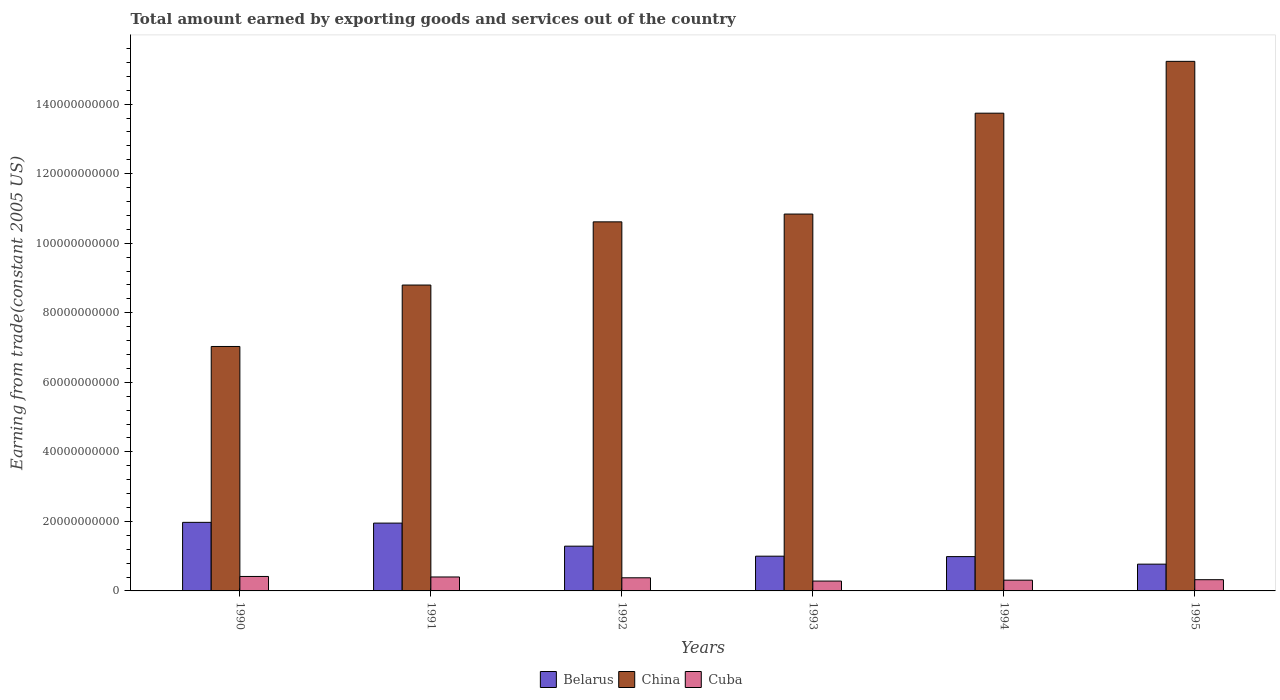How many groups of bars are there?
Offer a terse response. 6. Are the number of bars per tick equal to the number of legend labels?
Your answer should be very brief. Yes. Are the number of bars on each tick of the X-axis equal?
Your response must be concise. Yes. How many bars are there on the 1st tick from the left?
Offer a terse response. 3. How many bars are there on the 2nd tick from the right?
Provide a succinct answer. 3. In how many cases, is the number of bars for a given year not equal to the number of legend labels?
Your response must be concise. 0. What is the total amount earned by exporting goods and services in Belarus in 1993?
Ensure brevity in your answer.  9.99e+09. Across all years, what is the maximum total amount earned by exporting goods and services in Cuba?
Keep it short and to the point. 4.16e+09. Across all years, what is the minimum total amount earned by exporting goods and services in Cuba?
Your answer should be compact. 2.83e+09. In which year was the total amount earned by exporting goods and services in Belarus maximum?
Your answer should be compact. 1990. What is the total total amount earned by exporting goods and services in Cuba in the graph?
Keep it short and to the point. 2.11e+1. What is the difference between the total amount earned by exporting goods and services in China in 1991 and that in 1993?
Your response must be concise. -2.04e+1. What is the difference between the total amount earned by exporting goods and services in Cuba in 1993 and the total amount earned by exporting goods and services in Belarus in 1991?
Ensure brevity in your answer.  -1.67e+1. What is the average total amount earned by exporting goods and services in Cuba per year?
Provide a short and direct response. 3.52e+09. In the year 1994, what is the difference between the total amount earned by exporting goods and services in China and total amount earned by exporting goods and services in Belarus?
Provide a succinct answer. 1.28e+11. What is the ratio of the total amount earned by exporting goods and services in China in 1993 to that in 1994?
Your answer should be compact. 0.79. What is the difference between the highest and the second highest total amount earned by exporting goods and services in China?
Give a very brief answer. 1.49e+1. What is the difference between the highest and the lowest total amount earned by exporting goods and services in Belarus?
Ensure brevity in your answer.  1.20e+1. What does the 3rd bar from the left in 1992 represents?
Make the answer very short. Cuba. What does the 3rd bar from the right in 1993 represents?
Your answer should be compact. Belarus. How many bars are there?
Your answer should be very brief. 18. Are all the bars in the graph horizontal?
Keep it short and to the point. No. What is the difference between two consecutive major ticks on the Y-axis?
Ensure brevity in your answer.  2.00e+1. Where does the legend appear in the graph?
Give a very brief answer. Bottom center. How are the legend labels stacked?
Keep it short and to the point. Horizontal. What is the title of the graph?
Provide a succinct answer. Total amount earned by exporting goods and services out of the country. What is the label or title of the X-axis?
Make the answer very short. Years. What is the label or title of the Y-axis?
Your answer should be very brief. Earning from trade(constant 2005 US). What is the Earning from trade(constant 2005 US) of Belarus in 1990?
Your answer should be very brief. 1.97e+1. What is the Earning from trade(constant 2005 US) in China in 1990?
Your answer should be very brief. 7.03e+1. What is the Earning from trade(constant 2005 US) of Cuba in 1990?
Offer a very short reply. 4.16e+09. What is the Earning from trade(constant 2005 US) in Belarus in 1991?
Provide a short and direct response. 1.95e+1. What is the Earning from trade(constant 2005 US) of China in 1991?
Offer a terse response. 8.80e+1. What is the Earning from trade(constant 2005 US) of Cuba in 1991?
Give a very brief answer. 4.01e+09. What is the Earning from trade(constant 2005 US) in Belarus in 1992?
Give a very brief answer. 1.29e+1. What is the Earning from trade(constant 2005 US) of China in 1992?
Your answer should be very brief. 1.06e+11. What is the Earning from trade(constant 2005 US) of Cuba in 1992?
Make the answer very short. 3.77e+09. What is the Earning from trade(constant 2005 US) in Belarus in 1993?
Ensure brevity in your answer.  9.99e+09. What is the Earning from trade(constant 2005 US) in China in 1993?
Offer a very short reply. 1.08e+11. What is the Earning from trade(constant 2005 US) in Cuba in 1993?
Offer a terse response. 2.83e+09. What is the Earning from trade(constant 2005 US) of Belarus in 1994?
Keep it short and to the point. 9.87e+09. What is the Earning from trade(constant 2005 US) in China in 1994?
Make the answer very short. 1.37e+11. What is the Earning from trade(constant 2005 US) of Cuba in 1994?
Make the answer very short. 3.09e+09. What is the Earning from trade(constant 2005 US) in Belarus in 1995?
Give a very brief answer. 7.70e+09. What is the Earning from trade(constant 2005 US) of China in 1995?
Ensure brevity in your answer.  1.52e+11. What is the Earning from trade(constant 2005 US) of Cuba in 1995?
Ensure brevity in your answer.  3.23e+09. Across all years, what is the maximum Earning from trade(constant 2005 US) in Belarus?
Make the answer very short. 1.97e+1. Across all years, what is the maximum Earning from trade(constant 2005 US) of China?
Provide a succinct answer. 1.52e+11. Across all years, what is the maximum Earning from trade(constant 2005 US) of Cuba?
Your answer should be very brief. 4.16e+09. Across all years, what is the minimum Earning from trade(constant 2005 US) in Belarus?
Make the answer very short. 7.70e+09. Across all years, what is the minimum Earning from trade(constant 2005 US) of China?
Your answer should be very brief. 7.03e+1. Across all years, what is the minimum Earning from trade(constant 2005 US) of Cuba?
Make the answer very short. 2.83e+09. What is the total Earning from trade(constant 2005 US) of Belarus in the graph?
Your response must be concise. 7.97e+1. What is the total Earning from trade(constant 2005 US) in China in the graph?
Your response must be concise. 6.62e+11. What is the total Earning from trade(constant 2005 US) in Cuba in the graph?
Your response must be concise. 2.11e+1. What is the difference between the Earning from trade(constant 2005 US) of Belarus in 1990 and that in 1991?
Your response must be concise. 2.17e+08. What is the difference between the Earning from trade(constant 2005 US) of China in 1990 and that in 1991?
Your response must be concise. -1.77e+1. What is the difference between the Earning from trade(constant 2005 US) in Cuba in 1990 and that in 1991?
Keep it short and to the point. 1.47e+08. What is the difference between the Earning from trade(constant 2005 US) of Belarus in 1990 and that in 1992?
Provide a succinct answer. 6.85e+09. What is the difference between the Earning from trade(constant 2005 US) of China in 1990 and that in 1992?
Keep it short and to the point. -3.58e+1. What is the difference between the Earning from trade(constant 2005 US) in Cuba in 1990 and that in 1992?
Your answer should be very brief. 3.84e+08. What is the difference between the Earning from trade(constant 2005 US) of Belarus in 1990 and that in 1993?
Your answer should be very brief. 9.73e+09. What is the difference between the Earning from trade(constant 2005 US) in China in 1990 and that in 1993?
Make the answer very short. -3.81e+1. What is the difference between the Earning from trade(constant 2005 US) in Cuba in 1990 and that in 1993?
Make the answer very short. 1.32e+09. What is the difference between the Earning from trade(constant 2005 US) of Belarus in 1990 and that in 1994?
Provide a succinct answer. 9.85e+09. What is the difference between the Earning from trade(constant 2005 US) in China in 1990 and that in 1994?
Offer a terse response. -6.71e+1. What is the difference between the Earning from trade(constant 2005 US) of Cuba in 1990 and that in 1994?
Offer a very short reply. 1.07e+09. What is the difference between the Earning from trade(constant 2005 US) of Belarus in 1990 and that in 1995?
Your answer should be very brief. 1.20e+1. What is the difference between the Earning from trade(constant 2005 US) of China in 1990 and that in 1995?
Your answer should be very brief. -8.20e+1. What is the difference between the Earning from trade(constant 2005 US) in Cuba in 1990 and that in 1995?
Your answer should be compact. 9.32e+08. What is the difference between the Earning from trade(constant 2005 US) of Belarus in 1991 and that in 1992?
Keep it short and to the point. 6.63e+09. What is the difference between the Earning from trade(constant 2005 US) of China in 1991 and that in 1992?
Your answer should be very brief. -1.82e+1. What is the difference between the Earning from trade(constant 2005 US) of Cuba in 1991 and that in 1992?
Your response must be concise. 2.37e+08. What is the difference between the Earning from trade(constant 2005 US) in Belarus in 1991 and that in 1993?
Offer a very short reply. 9.51e+09. What is the difference between the Earning from trade(constant 2005 US) in China in 1991 and that in 1993?
Provide a succinct answer. -2.04e+1. What is the difference between the Earning from trade(constant 2005 US) in Cuba in 1991 and that in 1993?
Offer a very short reply. 1.18e+09. What is the difference between the Earning from trade(constant 2005 US) in Belarus in 1991 and that in 1994?
Keep it short and to the point. 9.63e+09. What is the difference between the Earning from trade(constant 2005 US) of China in 1991 and that in 1994?
Provide a succinct answer. -4.94e+1. What is the difference between the Earning from trade(constant 2005 US) of Cuba in 1991 and that in 1994?
Offer a terse response. 9.20e+08. What is the difference between the Earning from trade(constant 2005 US) in Belarus in 1991 and that in 1995?
Your answer should be compact. 1.18e+1. What is the difference between the Earning from trade(constant 2005 US) of China in 1991 and that in 1995?
Offer a terse response. -6.43e+1. What is the difference between the Earning from trade(constant 2005 US) in Cuba in 1991 and that in 1995?
Make the answer very short. 7.86e+08. What is the difference between the Earning from trade(constant 2005 US) in Belarus in 1992 and that in 1993?
Keep it short and to the point. 2.88e+09. What is the difference between the Earning from trade(constant 2005 US) in China in 1992 and that in 1993?
Your answer should be very brief. -2.24e+09. What is the difference between the Earning from trade(constant 2005 US) in Cuba in 1992 and that in 1993?
Keep it short and to the point. 9.41e+08. What is the difference between the Earning from trade(constant 2005 US) of Belarus in 1992 and that in 1994?
Keep it short and to the point. 3.00e+09. What is the difference between the Earning from trade(constant 2005 US) in China in 1992 and that in 1994?
Make the answer very short. -3.13e+1. What is the difference between the Earning from trade(constant 2005 US) in Cuba in 1992 and that in 1994?
Offer a terse response. 6.82e+08. What is the difference between the Earning from trade(constant 2005 US) of Belarus in 1992 and that in 1995?
Provide a succinct answer. 5.17e+09. What is the difference between the Earning from trade(constant 2005 US) in China in 1992 and that in 1995?
Your answer should be very brief. -4.62e+1. What is the difference between the Earning from trade(constant 2005 US) in Cuba in 1992 and that in 1995?
Your answer should be compact. 5.48e+08. What is the difference between the Earning from trade(constant 2005 US) in Belarus in 1993 and that in 1994?
Provide a succinct answer. 1.20e+08. What is the difference between the Earning from trade(constant 2005 US) of China in 1993 and that in 1994?
Keep it short and to the point. -2.90e+1. What is the difference between the Earning from trade(constant 2005 US) in Cuba in 1993 and that in 1994?
Make the answer very short. -2.58e+08. What is the difference between the Earning from trade(constant 2005 US) of Belarus in 1993 and that in 1995?
Your response must be concise. 2.29e+09. What is the difference between the Earning from trade(constant 2005 US) in China in 1993 and that in 1995?
Give a very brief answer. -4.39e+1. What is the difference between the Earning from trade(constant 2005 US) in Cuba in 1993 and that in 1995?
Offer a terse response. -3.92e+08. What is the difference between the Earning from trade(constant 2005 US) of Belarus in 1994 and that in 1995?
Your response must be concise. 2.17e+09. What is the difference between the Earning from trade(constant 2005 US) in China in 1994 and that in 1995?
Provide a succinct answer. -1.49e+1. What is the difference between the Earning from trade(constant 2005 US) of Cuba in 1994 and that in 1995?
Offer a very short reply. -1.34e+08. What is the difference between the Earning from trade(constant 2005 US) in Belarus in 1990 and the Earning from trade(constant 2005 US) in China in 1991?
Provide a short and direct response. -6.82e+1. What is the difference between the Earning from trade(constant 2005 US) of Belarus in 1990 and the Earning from trade(constant 2005 US) of Cuba in 1991?
Your response must be concise. 1.57e+1. What is the difference between the Earning from trade(constant 2005 US) in China in 1990 and the Earning from trade(constant 2005 US) in Cuba in 1991?
Offer a very short reply. 6.63e+1. What is the difference between the Earning from trade(constant 2005 US) in Belarus in 1990 and the Earning from trade(constant 2005 US) in China in 1992?
Ensure brevity in your answer.  -8.64e+1. What is the difference between the Earning from trade(constant 2005 US) of Belarus in 1990 and the Earning from trade(constant 2005 US) of Cuba in 1992?
Your answer should be compact. 1.59e+1. What is the difference between the Earning from trade(constant 2005 US) in China in 1990 and the Earning from trade(constant 2005 US) in Cuba in 1992?
Provide a short and direct response. 6.65e+1. What is the difference between the Earning from trade(constant 2005 US) in Belarus in 1990 and the Earning from trade(constant 2005 US) in China in 1993?
Give a very brief answer. -8.87e+1. What is the difference between the Earning from trade(constant 2005 US) of Belarus in 1990 and the Earning from trade(constant 2005 US) of Cuba in 1993?
Provide a succinct answer. 1.69e+1. What is the difference between the Earning from trade(constant 2005 US) in China in 1990 and the Earning from trade(constant 2005 US) in Cuba in 1993?
Make the answer very short. 6.75e+1. What is the difference between the Earning from trade(constant 2005 US) in Belarus in 1990 and the Earning from trade(constant 2005 US) in China in 1994?
Provide a succinct answer. -1.18e+11. What is the difference between the Earning from trade(constant 2005 US) of Belarus in 1990 and the Earning from trade(constant 2005 US) of Cuba in 1994?
Your response must be concise. 1.66e+1. What is the difference between the Earning from trade(constant 2005 US) in China in 1990 and the Earning from trade(constant 2005 US) in Cuba in 1994?
Provide a succinct answer. 6.72e+1. What is the difference between the Earning from trade(constant 2005 US) of Belarus in 1990 and the Earning from trade(constant 2005 US) of China in 1995?
Make the answer very short. -1.33e+11. What is the difference between the Earning from trade(constant 2005 US) of Belarus in 1990 and the Earning from trade(constant 2005 US) of Cuba in 1995?
Make the answer very short. 1.65e+1. What is the difference between the Earning from trade(constant 2005 US) of China in 1990 and the Earning from trade(constant 2005 US) of Cuba in 1995?
Ensure brevity in your answer.  6.71e+1. What is the difference between the Earning from trade(constant 2005 US) of Belarus in 1991 and the Earning from trade(constant 2005 US) of China in 1992?
Your answer should be compact. -8.66e+1. What is the difference between the Earning from trade(constant 2005 US) in Belarus in 1991 and the Earning from trade(constant 2005 US) in Cuba in 1992?
Ensure brevity in your answer.  1.57e+1. What is the difference between the Earning from trade(constant 2005 US) of China in 1991 and the Earning from trade(constant 2005 US) of Cuba in 1992?
Provide a succinct answer. 8.42e+1. What is the difference between the Earning from trade(constant 2005 US) in Belarus in 1991 and the Earning from trade(constant 2005 US) in China in 1993?
Your response must be concise. -8.89e+1. What is the difference between the Earning from trade(constant 2005 US) in Belarus in 1991 and the Earning from trade(constant 2005 US) in Cuba in 1993?
Ensure brevity in your answer.  1.67e+1. What is the difference between the Earning from trade(constant 2005 US) in China in 1991 and the Earning from trade(constant 2005 US) in Cuba in 1993?
Offer a terse response. 8.51e+1. What is the difference between the Earning from trade(constant 2005 US) in Belarus in 1991 and the Earning from trade(constant 2005 US) in China in 1994?
Provide a succinct answer. -1.18e+11. What is the difference between the Earning from trade(constant 2005 US) of Belarus in 1991 and the Earning from trade(constant 2005 US) of Cuba in 1994?
Your answer should be compact. 1.64e+1. What is the difference between the Earning from trade(constant 2005 US) of China in 1991 and the Earning from trade(constant 2005 US) of Cuba in 1994?
Provide a succinct answer. 8.49e+1. What is the difference between the Earning from trade(constant 2005 US) in Belarus in 1991 and the Earning from trade(constant 2005 US) in China in 1995?
Offer a terse response. -1.33e+11. What is the difference between the Earning from trade(constant 2005 US) in Belarus in 1991 and the Earning from trade(constant 2005 US) in Cuba in 1995?
Your answer should be compact. 1.63e+1. What is the difference between the Earning from trade(constant 2005 US) in China in 1991 and the Earning from trade(constant 2005 US) in Cuba in 1995?
Provide a short and direct response. 8.47e+1. What is the difference between the Earning from trade(constant 2005 US) in Belarus in 1992 and the Earning from trade(constant 2005 US) in China in 1993?
Give a very brief answer. -9.55e+1. What is the difference between the Earning from trade(constant 2005 US) in Belarus in 1992 and the Earning from trade(constant 2005 US) in Cuba in 1993?
Provide a succinct answer. 1.00e+1. What is the difference between the Earning from trade(constant 2005 US) in China in 1992 and the Earning from trade(constant 2005 US) in Cuba in 1993?
Keep it short and to the point. 1.03e+11. What is the difference between the Earning from trade(constant 2005 US) in Belarus in 1992 and the Earning from trade(constant 2005 US) in China in 1994?
Provide a short and direct response. -1.25e+11. What is the difference between the Earning from trade(constant 2005 US) of Belarus in 1992 and the Earning from trade(constant 2005 US) of Cuba in 1994?
Your answer should be compact. 9.78e+09. What is the difference between the Earning from trade(constant 2005 US) of China in 1992 and the Earning from trade(constant 2005 US) of Cuba in 1994?
Offer a very short reply. 1.03e+11. What is the difference between the Earning from trade(constant 2005 US) of Belarus in 1992 and the Earning from trade(constant 2005 US) of China in 1995?
Make the answer very short. -1.39e+11. What is the difference between the Earning from trade(constant 2005 US) of Belarus in 1992 and the Earning from trade(constant 2005 US) of Cuba in 1995?
Your answer should be compact. 9.65e+09. What is the difference between the Earning from trade(constant 2005 US) in China in 1992 and the Earning from trade(constant 2005 US) in Cuba in 1995?
Provide a succinct answer. 1.03e+11. What is the difference between the Earning from trade(constant 2005 US) of Belarus in 1993 and the Earning from trade(constant 2005 US) of China in 1994?
Offer a terse response. -1.27e+11. What is the difference between the Earning from trade(constant 2005 US) in Belarus in 1993 and the Earning from trade(constant 2005 US) in Cuba in 1994?
Ensure brevity in your answer.  6.90e+09. What is the difference between the Earning from trade(constant 2005 US) in China in 1993 and the Earning from trade(constant 2005 US) in Cuba in 1994?
Give a very brief answer. 1.05e+11. What is the difference between the Earning from trade(constant 2005 US) in Belarus in 1993 and the Earning from trade(constant 2005 US) in China in 1995?
Give a very brief answer. -1.42e+11. What is the difference between the Earning from trade(constant 2005 US) in Belarus in 1993 and the Earning from trade(constant 2005 US) in Cuba in 1995?
Your answer should be compact. 6.76e+09. What is the difference between the Earning from trade(constant 2005 US) of China in 1993 and the Earning from trade(constant 2005 US) of Cuba in 1995?
Your response must be concise. 1.05e+11. What is the difference between the Earning from trade(constant 2005 US) in Belarus in 1994 and the Earning from trade(constant 2005 US) in China in 1995?
Your answer should be very brief. -1.42e+11. What is the difference between the Earning from trade(constant 2005 US) of Belarus in 1994 and the Earning from trade(constant 2005 US) of Cuba in 1995?
Your answer should be compact. 6.64e+09. What is the difference between the Earning from trade(constant 2005 US) in China in 1994 and the Earning from trade(constant 2005 US) in Cuba in 1995?
Offer a very short reply. 1.34e+11. What is the average Earning from trade(constant 2005 US) of Belarus per year?
Keep it short and to the point. 1.33e+1. What is the average Earning from trade(constant 2005 US) of China per year?
Provide a succinct answer. 1.10e+11. What is the average Earning from trade(constant 2005 US) in Cuba per year?
Ensure brevity in your answer.  3.52e+09. In the year 1990, what is the difference between the Earning from trade(constant 2005 US) in Belarus and Earning from trade(constant 2005 US) in China?
Offer a very short reply. -5.06e+1. In the year 1990, what is the difference between the Earning from trade(constant 2005 US) of Belarus and Earning from trade(constant 2005 US) of Cuba?
Keep it short and to the point. 1.56e+1. In the year 1990, what is the difference between the Earning from trade(constant 2005 US) of China and Earning from trade(constant 2005 US) of Cuba?
Provide a short and direct response. 6.61e+1. In the year 1991, what is the difference between the Earning from trade(constant 2005 US) in Belarus and Earning from trade(constant 2005 US) in China?
Your response must be concise. -6.85e+1. In the year 1991, what is the difference between the Earning from trade(constant 2005 US) in Belarus and Earning from trade(constant 2005 US) in Cuba?
Offer a very short reply. 1.55e+1. In the year 1991, what is the difference between the Earning from trade(constant 2005 US) of China and Earning from trade(constant 2005 US) of Cuba?
Ensure brevity in your answer.  8.40e+1. In the year 1992, what is the difference between the Earning from trade(constant 2005 US) in Belarus and Earning from trade(constant 2005 US) in China?
Your answer should be very brief. -9.33e+1. In the year 1992, what is the difference between the Earning from trade(constant 2005 US) of Belarus and Earning from trade(constant 2005 US) of Cuba?
Ensure brevity in your answer.  9.10e+09. In the year 1992, what is the difference between the Earning from trade(constant 2005 US) of China and Earning from trade(constant 2005 US) of Cuba?
Provide a short and direct response. 1.02e+11. In the year 1993, what is the difference between the Earning from trade(constant 2005 US) of Belarus and Earning from trade(constant 2005 US) of China?
Your answer should be compact. -9.84e+1. In the year 1993, what is the difference between the Earning from trade(constant 2005 US) in Belarus and Earning from trade(constant 2005 US) in Cuba?
Provide a succinct answer. 7.16e+09. In the year 1993, what is the difference between the Earning from trade(constant 2005 US) of China and Earning from trade(constant 2005 US) of Cuba?
Your answer should be compact. 1.06e+11. In the year 1994, what is the difference between the Earning from trade(constant 2005 US) of Belarus and Earning from trade(constant 2005 US) of China?
Offer a terse response. -1.28e+11. In the year 1994, what is the difference between the Earning from trade(constant 2005 US) in Belarus and Earning from trade(constant 2005 US) in Cuba?
Keep it short and to the point. 6.78e+09. In the year 1994, what is the difference between the Earning from trade(constant 2005 US) in China and Earning from trade(constant 2005 US) in Cuba?
Ensure brevity in your answer.  1.34e+11. In the year 1995, what is the difference between the Earning from trade(constant 2005 US) in Belarus and Earning from trade(constant 2005 US) in China?
Give a very brief answer. -1.45e+11. In the year 1995, what is the difference between the Earning from trade(constant 2005 US) of Belarus and Earning from trade(constant 2005 US) of Cuba?
Your answer should be compact. 4.47e+09. In the year 1995, what is the difference between the Earning from trade(constant 2005 US) of China and Earning from trade(constant 2005 US) of Cuba?
Make the answer very short. 1.49e+11. What is the ratio of the Earning from trade(constant 2005 US) in Belarus in 1990 to that in 1991?
Offer a terse response. 1.01. What is the ratio of the Earning from trade(constant 2005 US) in China in 1990 to that in 1991?
Keep it short and to the point. 0.8. What is the ratio of the Earning from trade(constant 2005 US) of Cuba in 1990 to that in 1991?
Give a very brief answer. 1.04. What is the ratio of the Earning from trade(constant 2005 US) in Belarus in 1990 to that in 1992?
Provide a short and direct response. 1.53. What is the ratio of the Earning from trade(constant 2005 US) of China in 1990 to that in 1992?
Your answer should be very brief. 0.66. What is the ratio of the Earning from trade(constant 2005 US) in Cuba in 1990 to that in 1992?
Offer a terse response. 1.1. What is the ratio of the Earning from trade(constant 2005 US) in Belarus in 1990 to that in 1993?
Keep it short and to the point. 1.97. What is the ratio of the Earning from trade(constant 2005 US) of China in 1990 to that in 1993?
Offer a terse response. 0.65. What is the ratio of the Earning from trade(constant 2005 US) in Cuba in 1990 to that in 1993?
Provide a succinct answer. 1.47. What is the ratio of the Earning from trade(constant 2005 US) of Belarus in 1990 to that in 1994?
Keep it short and to the point. 2. What is the ratio of the Earning from trade(constant 2005 US) of China in 1990 to that in 1994?
Offer a very short reply. 0.51. What is the ratio of the Earning from trade(constant 2005 US) of Cuba in 1990 to that in 1994?
Offer a terse response. 1.34. What is the ratio of the Earning from trade(constant 2005 US) of Belarus in 1990 to that in 1995?
Provide a succinct answer. 2.56. What is the ratio of the Earning from trade(constant 2005 US) in China in 1990 to that in 1995?
Your answer should be very brief. 0.46. What is the ratio of the Earning from trade(constant 2005 US) in Cuba in 1990 to that in 1995?
Your answer should be compact. 1.29. What is the ratio of the Earning from trade(constant 2005 US) in Belarus in 1991 to that in 1992?
Keep it short and to the point. 1.52. What is the ratio of the Earning from trade(constant 2005 US) of China in 1991 to that in 1992?
Provide a short and direct response. 0.83. What is the ratio of the Earning from trade(constant 2005 US) in Cuba in 1991 to that in 1992?
Offer a terse response. 1.06. What is the ratio of the Earning from trade(constant 2005 US) in Belarus in 1991 to that in 1993?
Keep it short and to the point. 1.95. What is the ratio of the Earning from trade(constant 2005 US) in China in 1991 to that in 1993?
Keep it short and to the point. 0.81. What is the ratio of the Earning from trade(constant 2005 US) of Cuba in 1991 to that in 1993?
Offer a very short reply. 1.42. What is the ratio of the Earning from trade(constant 2005 US) of Belarus in 1991 to that in 1994?
Your response must be concise. 1.98. What is the ratio of the Earning from trade(constant 2005 US) in China in 1991 to that in 1994?
Your answer should be compact. 0.64. What is the ratio of the Earning from trade(constant 2005 US) of Cuba in 1991 to that in 1994?
Keep it short and to the point. 1.3. What is the ratio of the Earning from trade(constant 2005 US) of Belarus in 1991 to that in 1995?
Keep it short and to the point. 2.53. What is the ratio of the Earning from trade(constant 2005 US) of China in 1991 to that in 1995?
Provide a succinct answer. 0.58. What is the ratio of the Earning from trade(constant 2005 US) of Cuba in 1991 to that in 1995?
Your answer should be very brief. 1.24. What is the ratio of the Earning from trade(constant 2005 US) of Belarus in 1992 to that in 1993?
Keep it short and to the point. 1.29. What is the ratio of the Earning from trade(constant 2005 US) in China in 1992 to that in 1993?
Keep it short and to the point. 0.98. What is the ratio of the Earning from trade(constant 2005 US) of Cuba in 1992 to that in 1993?
Provide a succinct answer. 1.33. What is the ratio of the Earning from trade(constant 2005 US) in Belarus in 1992 to that in 1994?
Make the answer very short. 1.3. What is the ratio of the Earning from trade(constant 2005 US) of China in 1992 to that in 1994?
Offer a terse response. 0.77. What is the ratio of the Earning from trade(constant 2005 US) of Cuba in 1992 to that in 1994?
Ensure brevity in your answer.  1.22. What is the ratio of the Earning from trade(constant 2005 US) in Belarus in 1992 to that in 1995?
Give a very brief answer. 1.67. What is the ratio of the Earning from trade(constant 2005 US) of China in 1992 to that in 1995?
Give a very brief answer. 0.7. What is the ratio of the Earning from trade(constant 2005 US) in Cuba in 1992 to that in 1995?
Make the answer very short. 1.17. What is the ratio of the Earning from trade(constant 2005 US) of Belarus in 1993 to that in 1994?
Give a very brief answer. 1.01. What is the ratio of the Earning from trade(constant 2005 US) of China in 1993 to that in 1994?
Provide a short and direct response. 0.79. What is the ratio of the Earning from trade(constant 2005 US) in Cuba in 1993 to that in 1994?
Provide a succinct answer. 0.92. What is the ratio of the Earning from trade(constant 2005 US) of Belarus in 1993 to that in 1995?
Offer a terse response. 1.3. What is the ratio of the Earning from trade(constant 2005 US) in China in 1993 to that in 1995?
Offer a very short reply. 0.71. What is the ratio of the Earning from trade(constant 2005 US) in Cuba in 1993 to that in 1995?
Keep it short and to the point. 0.88. What is the ratio of the Earning from trade(constant 2005 US) of Belarus in 1994 to that in 1995?
Make the answer very short. 1.28. What is the ratio of the Earning from trade(constant 2005 US) in China in 1994 to that in 1995?
Your answer should be very brief. 0.9. What is the ratio of the Earning from trade(constant 2005 US) in Cuba in 1994 to that in 1995?
Give a very brief answer. 0.96. What is the difference between the highest and the second highest Earning from trade(constant 2005 US) in Belarus?
Give a very brief answer. 2.17e+08. What is the difference between the highest and the second highest Earning from trade(constant 2005 US) of China?
Give a very brief answer. 1.49e+1. What is the difference between the highest and the second highest Earning from trade(constant 2005 US) in Cuba?
Offer a terse response. 1.47e+08. What is the difference between the highest and the lowest Earning from trade(constant 2005 US) of Belarus?
Give a very brief answer. 1.20e+1. What is the difference between the highest and the lowest Earning from trade(constant 2005 US) in China?
Your answer should be compact. 8.20e+1. What is the difference between the highest and the lowest Earning from trade(constant 2005 US) in Cuba?
Make the answer very short. 1.32e+09. 